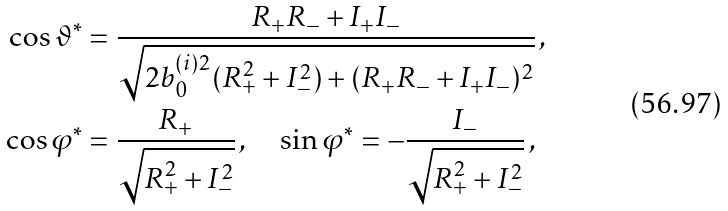Convert formula to latex. <formula><loc_0><loc_0><loc_500><loc_500>\cos \vartheta ^ { * } & = \frac { R _ { + } R _ { - } + I _ { + } I _ { - } } { \sqrt { 2 b _ { 0 } ^ { ( i ) 2 } ( R _ { + } ^ { 2 } + I _ { - } ^ { 2 } ) + ( R _ { + } R _ { - } + I _ { + } I _ { - } ) ^ { 2 } } } \, , \\ \cos \varphi ^ { * } & = \frac { R _ { + } } { \sqrt { R _ { + } ^ { 2 } + I _ { - } ^ { 2 } } } \, , \quad \sin \varphi ^ { * } = - \frac { I _ { - } } { \sqrt { R _ { + } ^ { 2 } + I _ { - } ^ { 2 } } } \, ,</formula> 